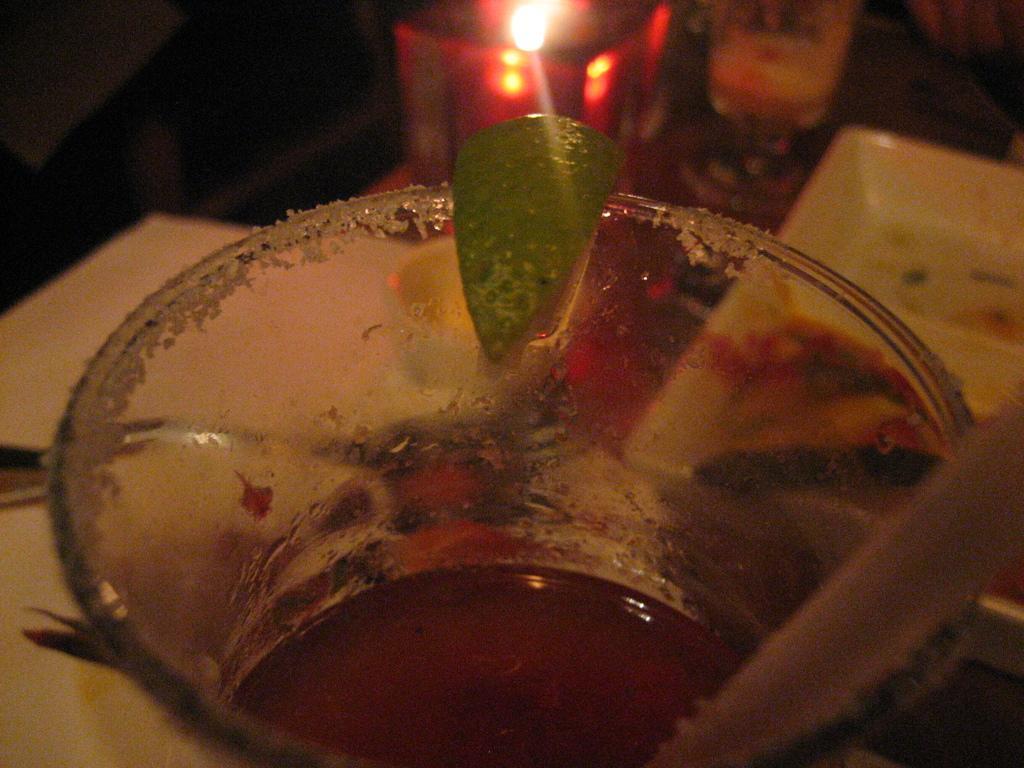Describe this image in one or two sentences. This picture is blur. In this picture we can see a green leaf, straw and a glass with drink. In the background we can see a candle and a plate. 